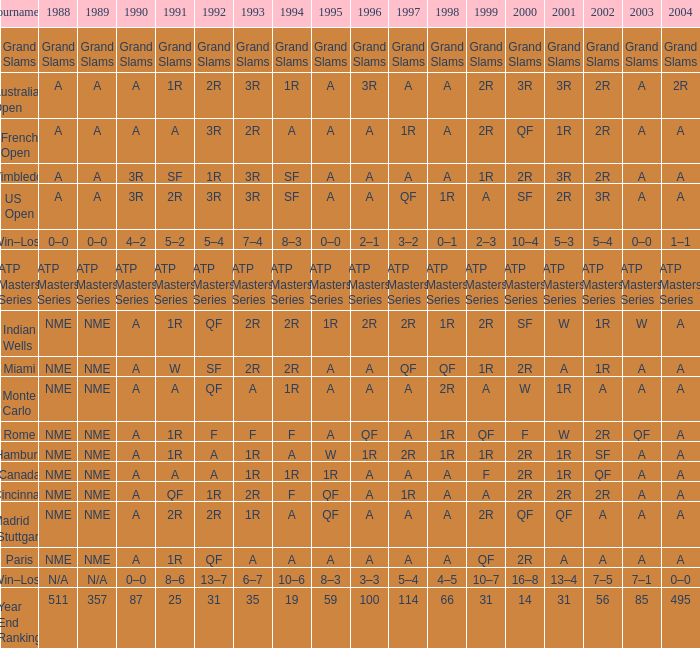What shows for 1988 when 1994 shows 10–6? N/A. Would you mind parsing the complete table? {'header': ['Tournament', '1988', '1989', '1990', '1991', '1992', '1993', '1994', '1995', '1996', '1997', '1998', '1999', '2000', '2001', '2002', '2003', '2004'], 'rows': [['Grand Slams', 'Grand Slams', 'Grand Slams', 'Grand Slams', 'Grand Slams', 'Grand Slams', 'Grand Slams', 'Grand Slams', 'Grand Slams', 'Grand Slams', 'Grand Slams', 'Grand Slams', 'Grand Slams', 'Grand Slams', 'Grand Slams', 'Grand Slams', 'Grand Slams', 'Grand Slams'], ['Australian Open', 'A', 'A', 'A', '1R', '2R', '3R', '1R', 'A', '3R', 'A', 'A', '2R', '3R', '3R', '2R', 'A', '2R'], ['French Open', 'A', 'A', 'A', 'A', '3R', '2R', 'A', 'A', 'A', '1R', 'A', '2R', 'QF', '1R', '2R', 'A', 'A'], ['Wimbledon', 'A', 'A', '3R', 'SF', '1R', '3R', 'SF', 'A', 'A', 'A', 'A', '1R', '2R', '3R', '2R', 'A', 'A'], ['US Open', 'A', 'A', '3R', '2R', '3R', '3R', 'SF', 'A', 'A', 'QF', '1R', 'A', 'SF', '2R', '3R', 'A', 'A'], ['Win–Loss', '0–0', '0–0', '4–2', '5–2', '5–4', '7–4', '8–3', '0–0', '2–1', '3–2', '0–1', '2–3', '10–4', '5–3', '5–4', '0–0', '1–1'], ['ATP Masters Series', 'ATP Masters Series', 'ATP Masters Series', 'ATP Masters Series', 'ATP Masters Series', 'ATP Masters Series', 'ATP Masters Series', 'ATP Masters Series', 'ATP Masters Series', 'ATP Masters Series', 'ATP Masters Series', 'ATP Masters Series', 'ATP Masters Series', 'ATP Masters Series', 'ATP Masters Series', 'ATP Masters Series', 'ATP Masters Series', 'ATP Masters Series'], ['Indian Wells', 'NME', 'NME', 'A', '1R', 'QF', '2R', '2R', '1R', '2R', '2R', '1R', '2R', 'SF', 'W', '1R', 'W', 'A'], ['Miami', 'NME', 'NME', 'A', 'W', 'SF', '2R', '2R', 'A', 'A', 'QF', 'QF', '1R', '2R', 'A', '1R', 'A', 'A'], ['Monte Carlo', 'NME', 'NME', 'A', 'A', 'QF', 'A', '1R', 'A', 'A', 'A', '2R', 'A', 'W', '1R', 'A', 'A', 'A'], ['Rome', 'NME', 'NME', 'A', '1R', 'F', 'F', 'F', 'A', 'QF', 'A', '1R', 'QF', 'F', 'W', '2R', 'QF', 'A'], ['Hamburg', 'NME', 'NME', 'A', '1R', 'A', '1R', 'A', 'W', '1R', '2R', '1R', '1R', '2R', '1R', 'SF', 'A', 'A'], ['Canada', 'NME', 'NME', 'A', 'A', 'A', '1R', '1R', '1R', 'A', 'A', 'A', 'F', '2R', '1R', 'QF', 'A', 'A'], ['Cincinnati', 'NME', 'NME', 'A', 'QF', '1R', '2R', 'F', 'QF', 'A', '1R', 'A', 'A', '2R', '2R', '2R', 'A', 'A'], ['Madrid (Stuttgart)', 'NME', 'NME', 'A', '2R', '2R', '1R', 'A', 'QF', 'A', 'A', 'A', '2R', 'QF', 'QF', 'A', 'A', 'A'], ['Paris', 'NME', 'NME', 'A', '1R', 'QF', 'A', 'A', 'A', 'A', 'A', 'A', 'QF', '2R', 'A', 'A', 'A', 'A'], ['Win–Loss', 'N/A', 'N/A', '0–0', '8–6', '13–7', '6–7', '10–6', '8–3', '3–3', '5–4', '4–5', '10–7', '16–8', '13–4', '7–5', '7–1', '0–0'], ['Year End Ranking', '511', '357', '87', '25', '31', '35', '19', '59', '100', '114', '66', '31', '14', '31', '56', '85', '495']]} 